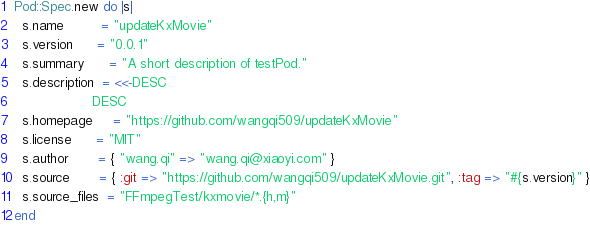<code> <loc_0><loc_0><loc_500><loc_500><_Ruby_>Pod::Spec.new do |s|
  s.name         = "updateKxMovie"
  s.version      = "0.0.1"
  s.summary      = "A short description of testPod."
  s.description  = <<-DESC
                   DESC
  s.homepage     = "https://github.com/wangqi509/updateKxMovie"
  s.license      = "MIT"
  s.author       = { "wang.qi" => "wang.qi@xiaoyi.com" }
  s.source       = { :git => "https://github.com/wangqi509/updateKxMovie.git", :tag => "#{s.version}" }
  s.source_files  = "FFmpegTest/kxmovie/*.{h,m}"
end
</code> 